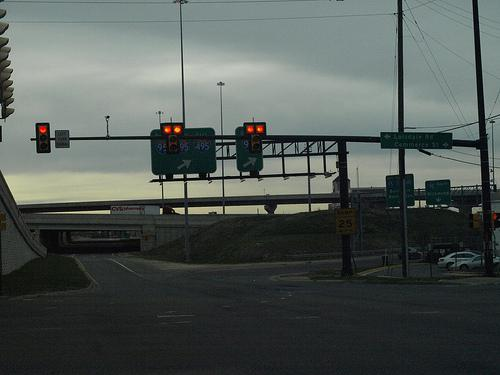Question: what is the speed limit on the ramp?
Choices:
A. 30 mph.
B. 35 mph.
C. 20 mph.
D. 25 MPH.
Answer with the letter. Answer: D Question: what color is the sky?
Choices:
A. Black.
B. Pink.
C. Blue.
D. Grey.
Answer with the letter. Answer: D Question: what is blocking the highway signs?
Choices:
A. Stop signs.
B. Stop lights.
C. Street signs.
D. Red light camera signs.
Answer with the letter. Answer: B 